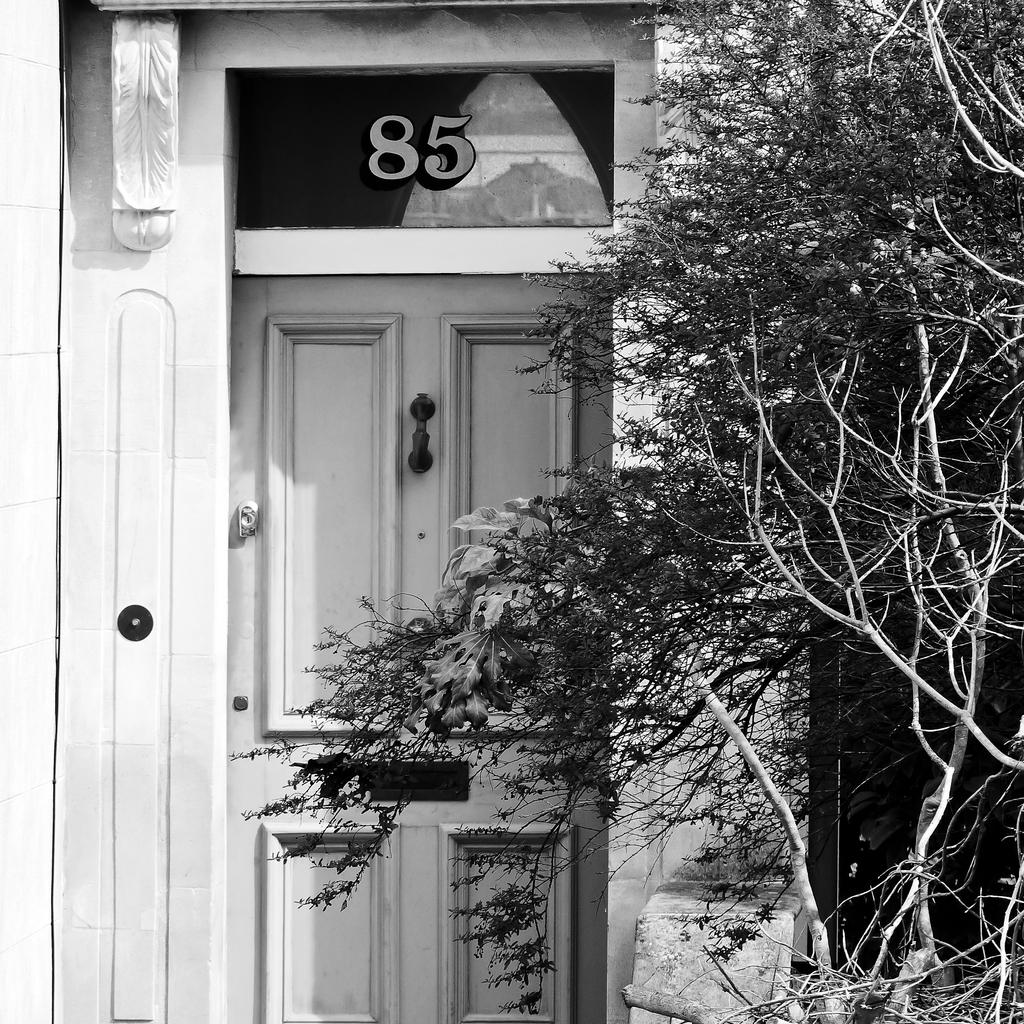What is the main object in the picture? There is a house door in the picture. What color is the house door? The house door is white in color. Is there any number on the house door? Yes, there is a number 85 on the top of the door. What can be seen beside the house door? There are plants beside the door. What type of guitar is hanging on the frame beside the door? There is no guitar or frame present beside the door in the image. 